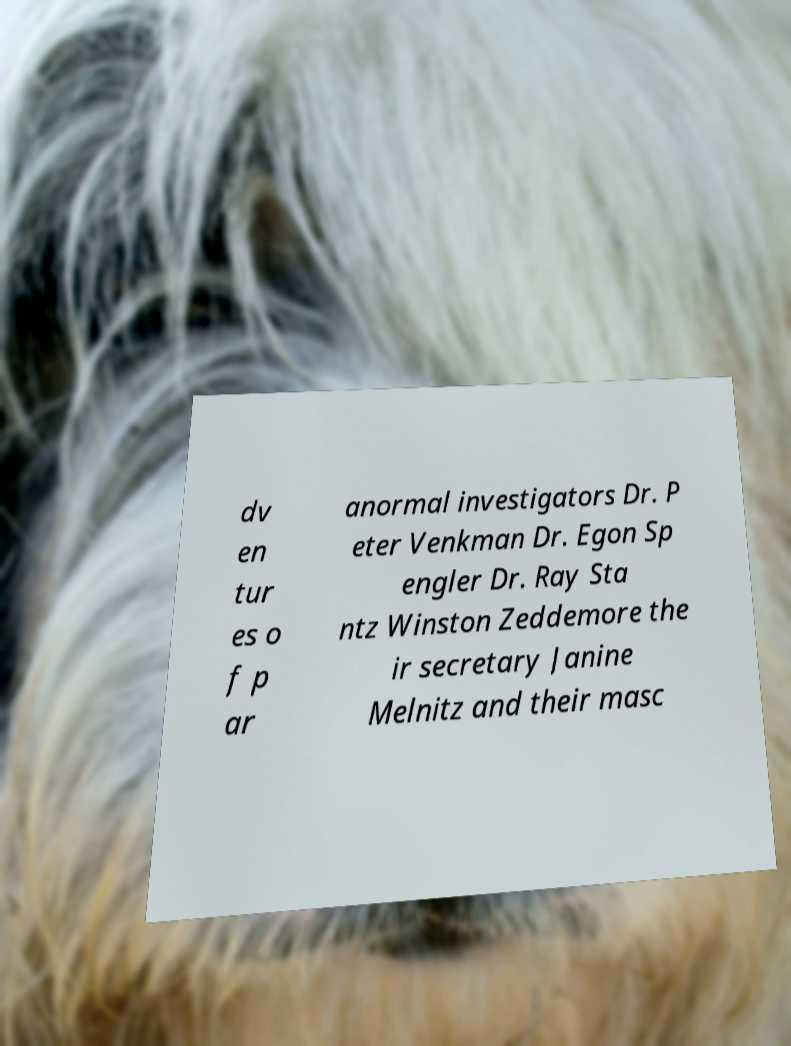I need the written content from this picture converted into text. Can you do that? dv en tur es o f p ar anormal investigators Dr. P eter Venkman Dr. Egon Sp engler Dr. Ray Sta ntz Winston Zeddemore the ir secretary Janine Melnitz and their masc 